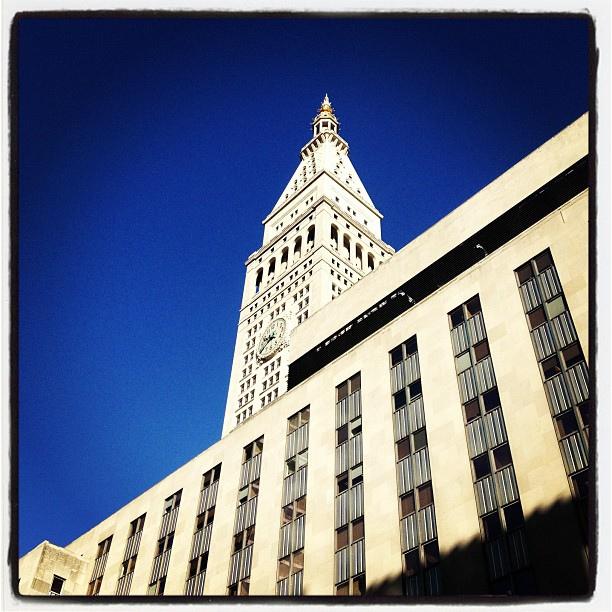Do you see a clock?
Be succinct. Yes. What color is the sky?
Give a very brief answer. Blue. What time of day was this photo taken?
Answer briefly. Morning. Is this picture vintage?
Write a very short answer. No. 